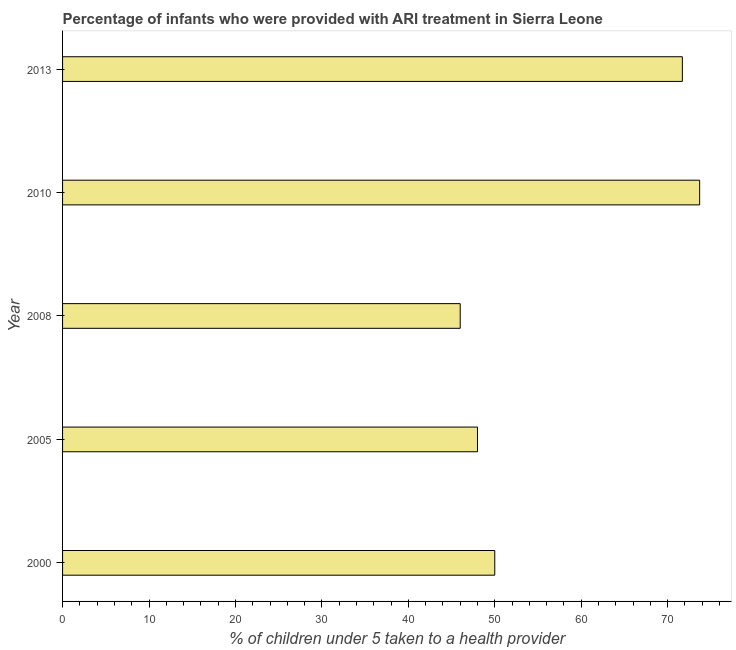Does the graph contain any zero values?
Offer a very short reply. No. Does the graph contain grids?
Offer a very short reply. No. What is the title of the graph?
Provide a succinct answer. Percentage of infants who were provided with ARI treatment in Sierra Leone. What is the label or title of the X-axis?
Ensure brevity in your answer.  % of children under 5 taken to a health provider. What is the percentage of children who were provided with ari treatment in 2005?
Give a very brief answer. 48. Across all years, what is the maximum percentage of children who were provided with ari treatment?
Provide a short and direct response. 73.7. Across all years, what is the minimum percentage of children who were provided with ari treatment?
Give a very brief answer. 46. What is the sum of the percentage of children who were provided with ari treatment?
Your answer should be compact. 289.4. What is the difference between the percentage of children who were provided with ari treatment in 2005 and 2013?
Your answer should be very brief. -23.7. What is the average percentage of children who were provided with ari treatment per year?
Your response must be concise. 57.88. In how many years, is the percentage of children who were provided with ari treatment greater than 48 %?
Your response must be concise. 3. What is the ratio of the percentage of children who were provided with ari treatment in 2000 to that in 2008?
Keep it short and to the point. 1.09. Is the difference between the percentage of children who were provided with ari treatment in 2000 and 2008 greater than the difference between any two years?
Your response must be concise. No. What is the difference between the highest and the lowest percentage of children who were provided with ari treatment?
Make the answer very short. 27.7. In how many years, is the percentage of children who were provided with ari treatment greater than the average percentage of children who were provided with ari treatment taken over all years?
Keep it short and to the point. 2. How many bars are there?
Give a very brief answer. 5. Are the values on the major ticks of X-axis written in scientific E-notation?
Offer a very short reply. No. What is the % of children under 5 taken to a health provider of 2005?
Make the answer very short. 48. What is the % of children under 5 taken to a health provider of 2008?
Make the answer very short. 46. What is the % of children under 5 taken to a health provider in 2010?
Offer a very short reply. 73.7. What is the % of children under 5 taken to a health provider in 2013?
Ensure brevity in your answer.  71.7. What is the difference between the % of children under 5 taken to a health provider in 2000 and 2010?
Your answer should be compact. -23.7. What is the difference between the % of children under 5 taken to a health provider in 2000 and 2013?
Your response must be concise. -21.7. What is the difference between the % of children under 5 taken to a health provider in 2005 and 2010?
Give a very brief answer. -25.7. What is the difference between the % of children under 5 taken to a health provider in 2005 and 2013?
Your response must be concise. -23.7. What is the difference between the % of children under 5 taken to a health provider in 2008 and 2010?
Offer a very short reply. -27.7. What is the difference between the % of children under 5 taken to a health provider in 2008 and 2013?
Your answer should be very brief. -25.7. What is the difference between the % of children under 5 taken to a health provider in 2010 and 2013?
Ensure brevity in your answer.  2. What is the ratio of the % of children under 5 taken to a health provider in 2000 to that in 2005?
Make the answer very short. 1.04. What is the ratio of the % of children under 5 taken to a health provider in 2000 to that in 2008?
Provide a short and direct response. 1.09. What is the ratio of the % of children under 5 taken to a health provider in 2000 to that in 2010?
Your answer should be compact. 0.68. What is the ratio of the % of children under 5 taken to a health provider in 2000 to that in 2013?
Ensure brevity in your answer.  0.7. What is the ratio of the % of children under 5 taken to a health provider in 2005 to that in 2008?
Offer a terse response. 1.04. What is the ratio of the % of children under 5 taken to a health provider in 2005 to that in 2010?
Provide a succinct answer. 0.65. What is the ratio of the % of children under 5 taken to a health provider in 2005 to that in 2013?
Provide a succinct answer. 0.67. What is the ratio of the % of children under 5 taken to a health provider in 2008 to that in 2010?
Provide a succinct answer. 0.62. What is the ratio of the % of children under 5 taken to a health provider in 2008 to that in 2013?
Give a very brief answer. 0.64. What is the ratio of the % of children under 5 taken to a health provider in 2010 to that in 2013?
Your response must be concise. 1.03. 